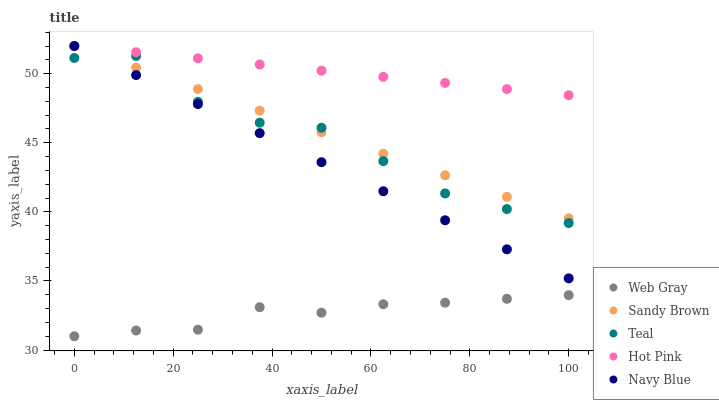Does Web Gray have the minimum area under the curve?
Answer yes or no. Yes. Does Hot Pink have the maximum area under the curve?
Answer yes or no. Yes. Does Sandy Brown have the minimum area under the curve?
Answer yes or no. No. Does Sandy Brown have the maximum area under the curve?
Answer yes or no. No. Is Navy Blue the smoothest?
Answer yes or no. Yes. Is Teal the roughest?
Answer yes or no. Yes. Is Web Gray the smoothest?
Answer yes or no. No. Is Web Gray the roughest?
Answer yes or no. No. Does Web Gray have the lowest value?
Answer yes or no. Yes. Does Sandy Brown have the lowest value?
Answer yes or no. No. Does Hot Pink have the highest value?
Answer yes or no. Yes. Does Web Gray have the highest value?
Answer yes or no. No. Is Web Gray less than Sandy Brown?
Answer yes or no. Yes. Is Sandy Brown greater than Web Gray?
Answer yes or no. Yes. Does Hot Pink intersect Sandy Brown?
Answer yes or no. Yes. Is Hot Pink less than Sandy Brown?
Answer yes or no. No. Is Hot Pink greater than Sandy Brown?
Answer yes or no. No. Does Web Gray intersect Sandy Brown?
Answer yes or no. No. 